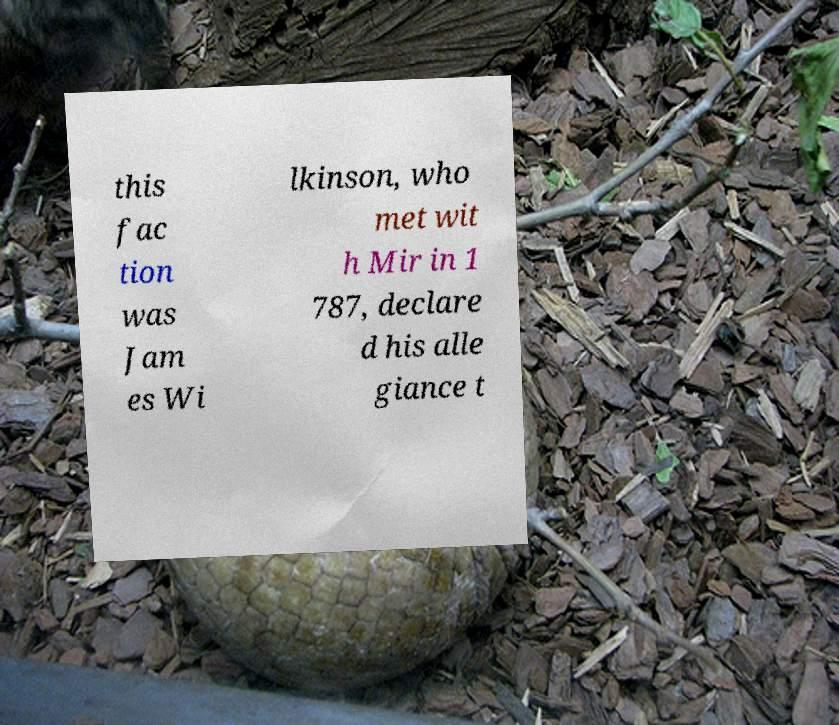Can you accurately transcribe the text from the provided image for me? this fac tion was Jam es Wi lkinson, who met wit h Mir in 1 787, declare d his alle giance t 